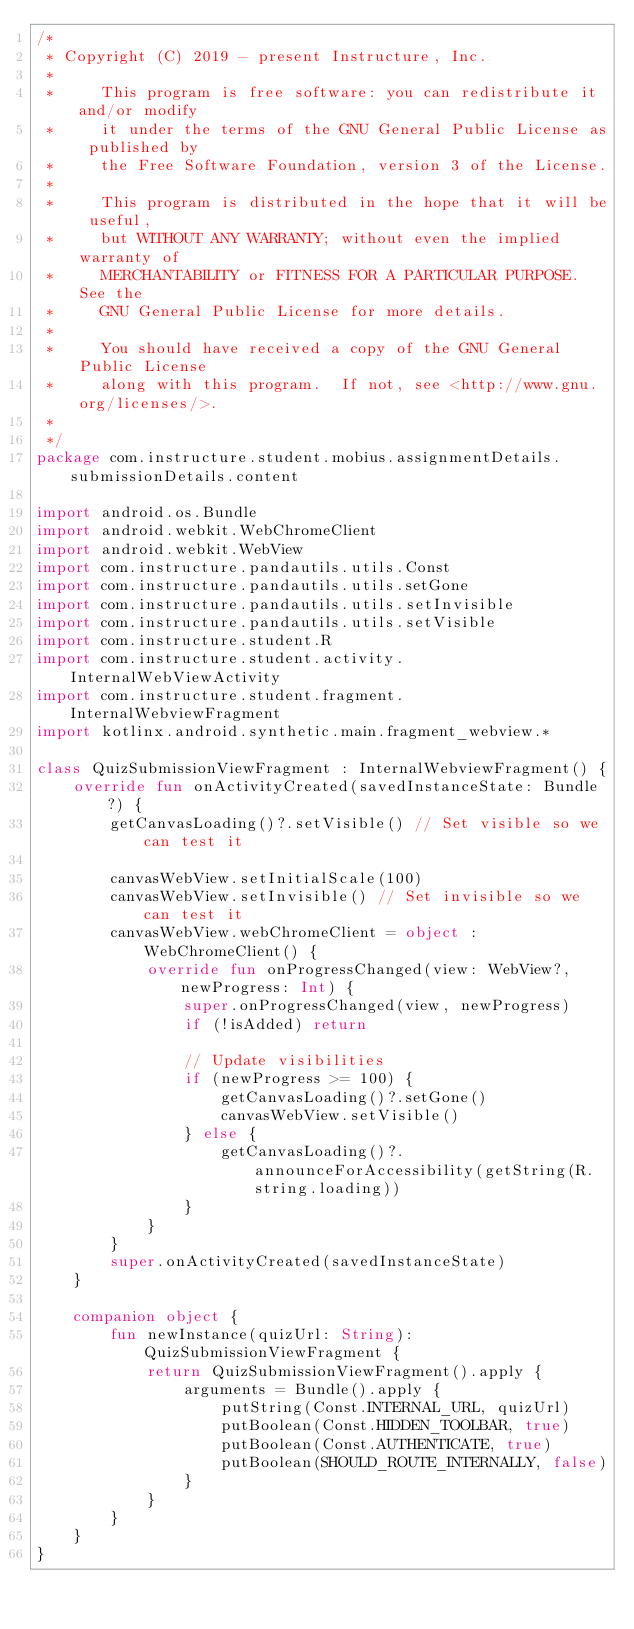Convert code to text. <code><loc_0><loc_0><loc_500><loc_500><_Kotlin_>/*
 * Copyright (C) 2019 - present Instructure, Inc.
 *
 *     This program is free software: you can redistribute it and/or modify
 *     it under the terms of the GNU General Public License as published by
 *     the Free Software Foundation, version 3 of the License.
 *
 *     This program is distributed in the hope that it will be useful,
 *     but WITHOUT ANY WARRANTY; without even the implied warranty of
 *     MERCHANTABILITY or FITNESS FOR A PARTICULAR PURPOSE.  See the
 *     GNU General Public License for more details.
 *
 *     You should have received a copy of the GNU General Public License
 *     along with this program.  If not, see <http://www.gnu.org/licenses/>.
 *
 */
package com.instructure.student.mobius.assignmentDetails.submissionDetails.content

import android.os.Bundle
import android.webkit.WebChromeClient
import android.webkit.WebView
import com.instructure.pandautils.utils.Const
import com.instructure.pandautils.utils.setGone
import com.instructure.pandautils.utils.setInvisible
import com.instructure.pandautils.utils.setVisible
import com.instructure.student.R
import com.instructure.student.activity.InternalWebViewActivity
import com.instructure.student.fragment.InternalWebviewFragment
import kotlinx.android.synthetic.main.fragment_webview.*

class QuizSubmissionViewFragment : InternalWebviewFragment() {
    override fun onActivityCreated(savedInstanceState: Bundle?) {
        getCanvasLoading()?.setVisible() // Set visible so we can test it

        canvasWebView.setInitialScale(100)
        canvasWebView.setInvisible() // Set invisible so we can test it
        canvasWebView.webChromeClient = object : WebChromeClient() {
            override fun onProgressChanged(view: WebView?, newProgress: Int) {
                super.onProgressChanged(view, newProgress)
                if (!isAdded) return

                // Update visibilities
                if (newProgress >= 100) {
                    getCanvasLoading()?.setGone()
                    canvasWebView.setVisible()
                } else {
                    getCanvasLoading()?.announceForAccessibility(getString(R.string.loading))
                }
            }
        }
        super.onActivityCreated(savedInstanceState)
    }

    companion object {
        fun newInstance(quizUrl: String): QuizSubmissionViewFragment {
            return QuizSubmissionViewFragment().apply {
                arguments = Bundle().apply {
                    putString(Const.INTERNAL_URL, quizUrl)
                    putBoolean(Const.HIDDEN_TOOLBAR, true)
                    putBoolean(Const.AUTHENTICATE, true)
                    putBoolean(SHOULD_ROUTE_INTERNALLY, false)
                }
            }
        }
    }
}</code> 